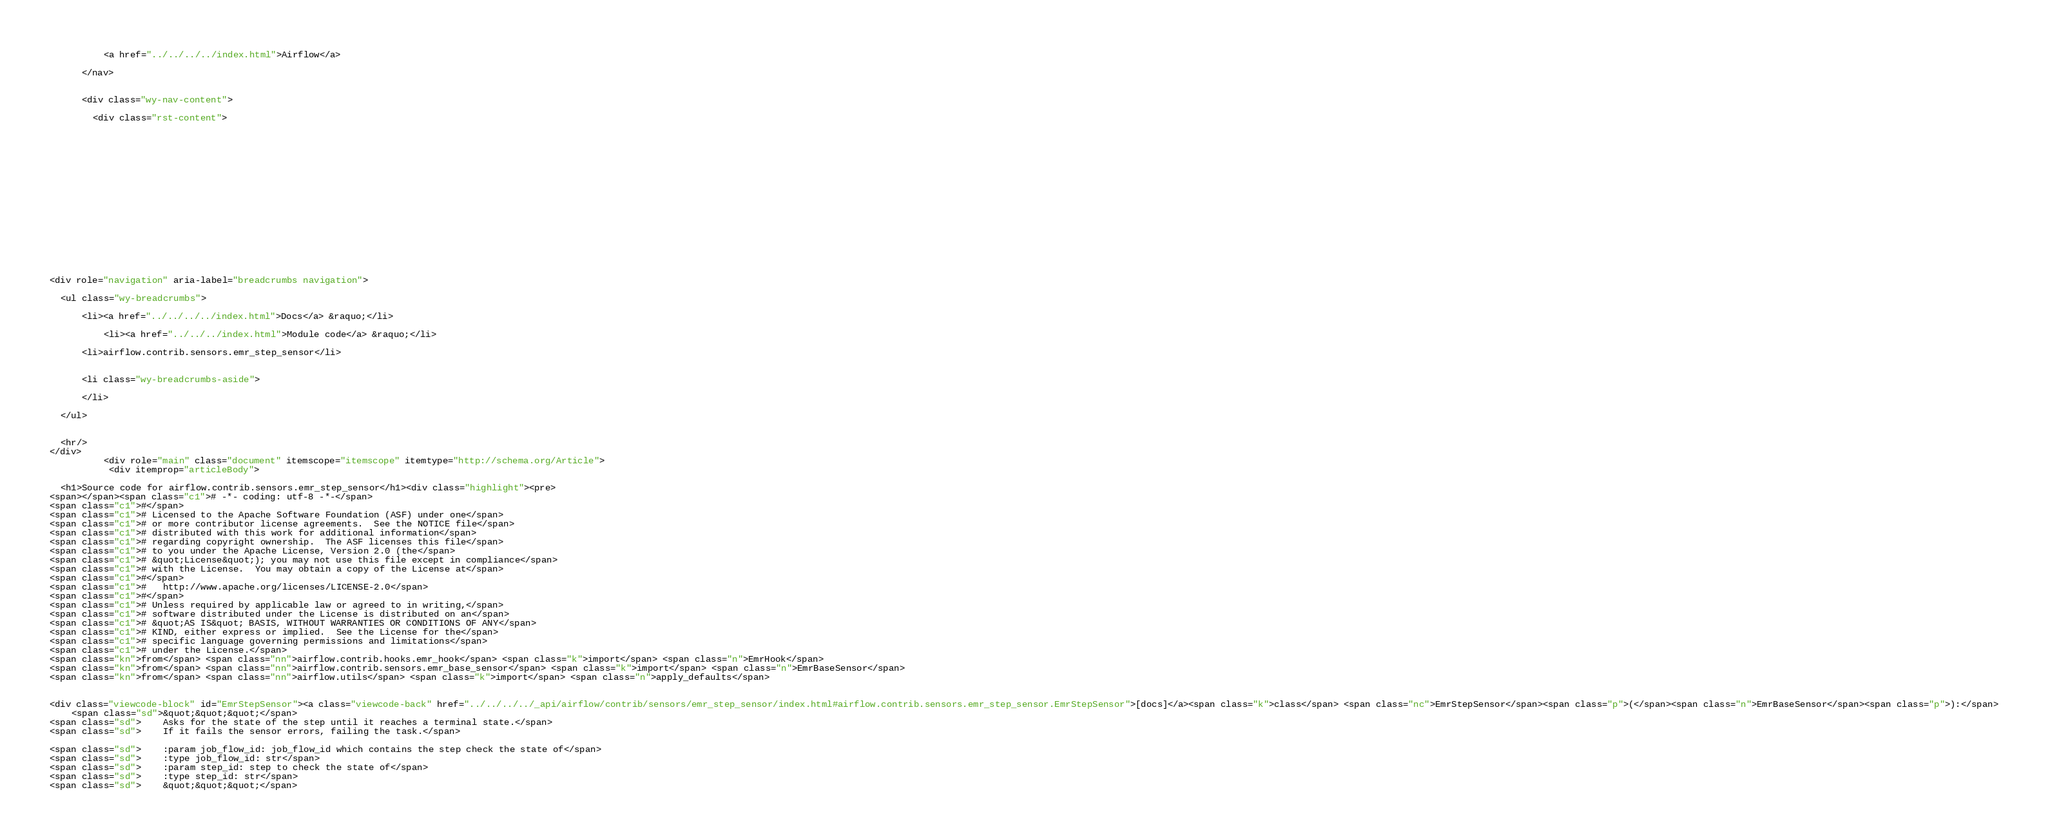Convert code to text. <code><loc_0><loc_0><loc_500><loc_500><_HTML_>          <a href="../../../../index.html">Airflow</a>
        
      </nav>


      <div class="wy-nav-content">
        
        <div class="rst-content">
        
          















<div role="navigation" aria-label="breadcrumbs navigation">

  <ul class="wy-breadcrumbs">
    
      <li><a href="../../../../index.html">Docs</a> &raquo;</li>
        
          <li><a href="../../../index.html">Module code</a> &raquo;</li>
        
      <li>airflow.contrib.sensors.emr_step_sensor</li>
    
    
      <li class="wy-breadcrumbs-aside">
        
      </li>
    
  </ul>

  
  <hr/>
</div>
          <div role="main" class="document" itemscope="itemscope" itemtype="http://schema.org/Article">
           <div itemprop="articleBody">
            
  <h1>Source code for airflow.contrib.sensors.emr_step_sensor</h1><div class="highlight"><pre>
<span></span><span class="c1"># -*- coding: utf-8 -*-</span>
<span class="c1">#</span>
<span class="c1"># Licensed to the Apache Software Foundation (ASF) under one</span>
<span class="c1"># or more contributor license agreements.  See the NOTICE file</span>
<span class="c1"># distributed with this work for additional information</span>
<span class="c1"># regarding copyright ownership.  The ASF licenses this file</span>
<span class="c1"># to you under the Apache License, Version 2.0 (the</span>
<span class="c1"># &quot;License&quot;); you may not use this file except in compliance</span>
<span class="c1"># with the License.  You may obtain a copy of the License at</span>
<span class="c1">#</span>
<span class="c1">#   http://www.apache.org/licenses/LICENSE-2.0</span>
<span class="c1">#</span>
<span class="c1"># Unless required by applicable law or agreed to in writing,</span>
<span class="c1"># software distributed under the License is distributed on an</span>
<span class="c1"># &quot;AS IS&quot; BASIS, WITHOUT WARRANTIES OR CONDITIONS OF ANY</span>
<span class="c1"># KIND, either express or implied.  See the License for the</span>
<span class="c1"># specific language governing permissions and limitations</span>
<span class="c1"># under the License.</span>
<span class="kn">from</span> <span class="nn">airflow.contrib.hooks.emr_hook</span> <span class="k">import</span> <span class="n">EmrHook</span>
<span class="kn">from</span> <span class="nn">airflow.contrib.sensors.emr_base_sensor</span> <span class="k">import</span> <span class="n">EmrBaseSensor</span>
<span class="kn">from</span> <span class="nn">airflow.utils</span> <span class="k">import</span> <span class="n">apply_defaults</span>


<div class="viewcode-block" id="EmrStepSensor"><a class="viewcode-back" href="../../../../_api/airflow/contrib/sensors/emr_step_sensor/index.html#airflow.contrib.sensors.emr_step_sensor.EmrStepSensor">[docs]</a><span class="k">class</span> <span class="nc">EmrStepSensor</span><span class="p">(</span><span class="n">EmrBaseSensor</span><span class="p">):</span>
    <span class="sd">&quot;&quot;&quot;</span>
<span class="sd">    Asks for the state of the step until it reaches a terminal state.</span>
<span class="sd">    If it fails the sensor errors, failing the task.</span>

<span class="sd">    :param job_flow_id: job_flow_id which contains the step check the state of</span>
<span class="sd">    :type job_flow_id: str</span>
<span class="sd">    :param step_id: step to check the state of</span>
<span class="sd">    :type step_id: str</span>
<span class="sd">    &quot;&quot;&quot;</span>
</code> 